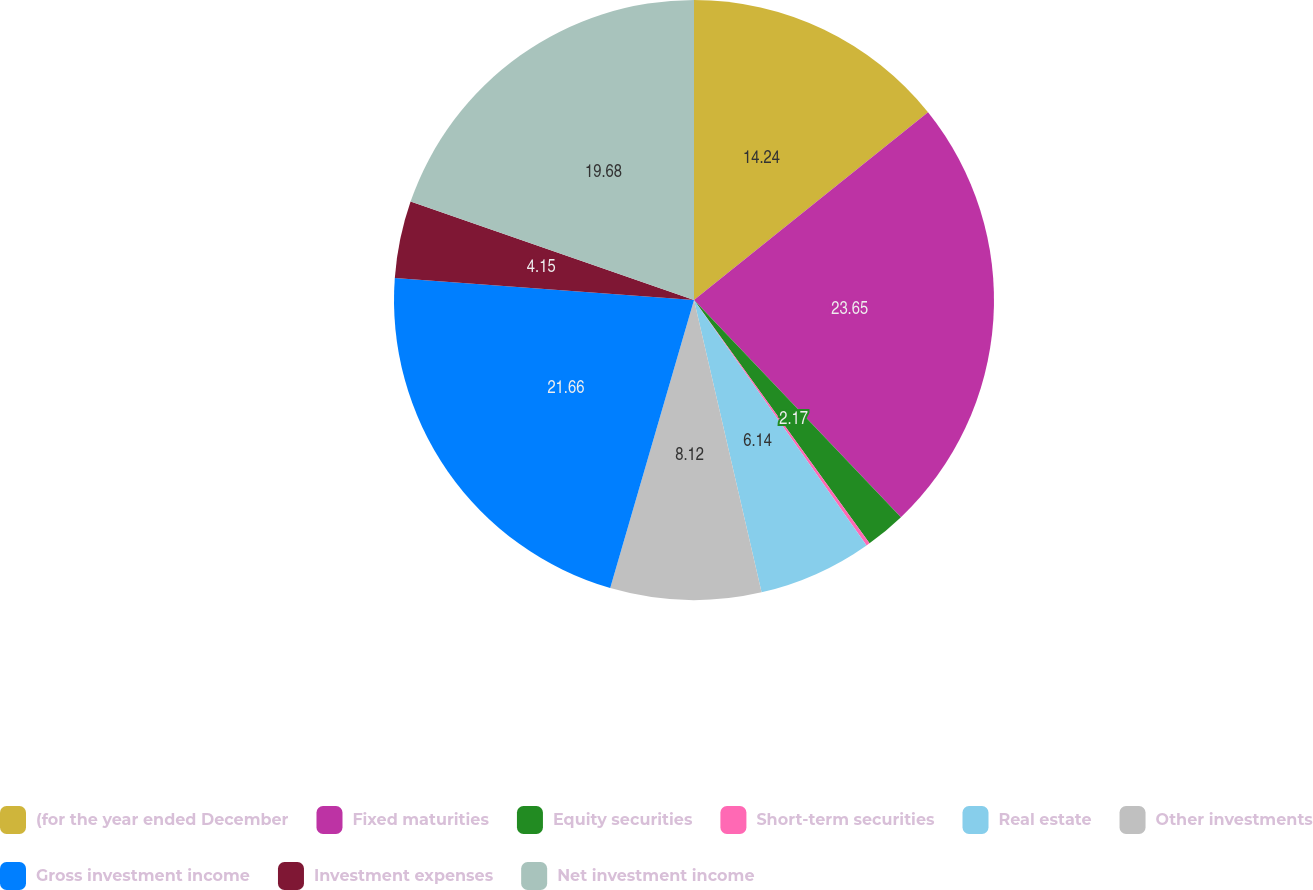<chart> <loc_0><loc_0><loc_500><loc_500><pie_chart><fcel>(for the year ended December<fcel>Fixed maturities<fcel>Equity securities<fcel>Short-term securities<fcel>Real estate<fcel>Other investments<fcel>Gross investment income<fcel>Investment expenses<fcel>Net investment income<nl><fcel>14.24%<fcel>23.64%<fcel>2.17%<fcel>0.19%<fcel>6.14%<fcel>8.12%<fcel>21.66%<fcel>4.15%<fcel>19.68%<nl></chart> 